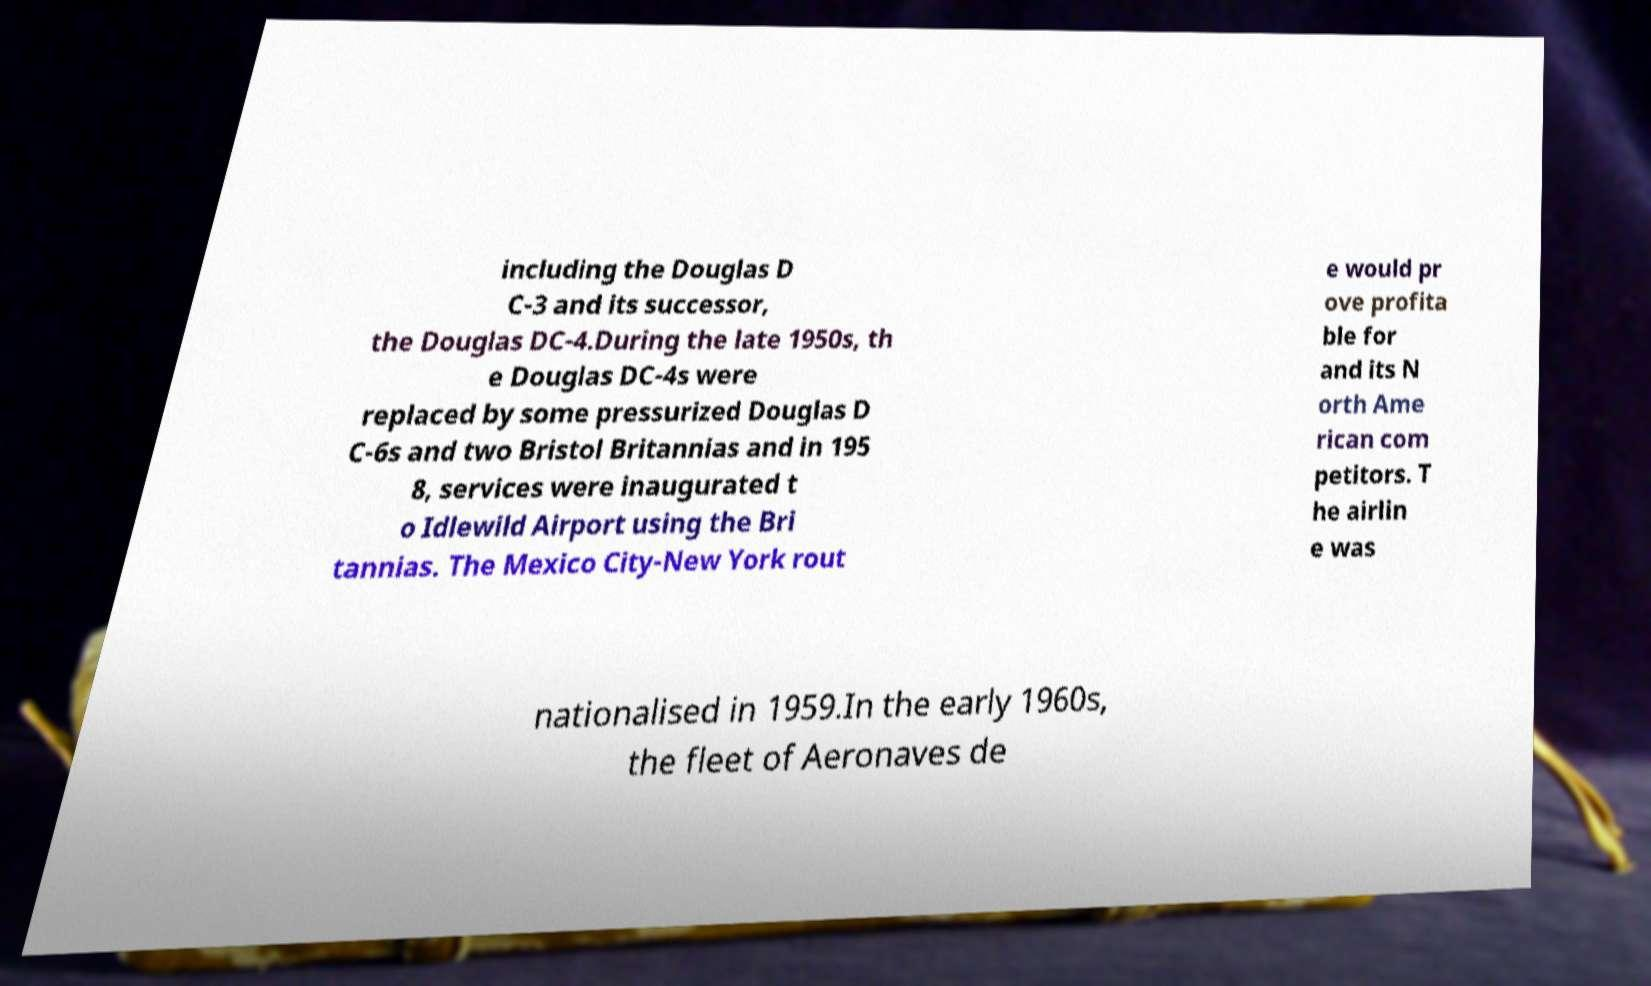There's text embedded in this image that I need extracted. Can you transcribe it verbatim? including the Douglas D C-3 and its successor, the Douglas DC-4.During the late 1950s, th e Douglas DC-4s were replaced by some pressurized Douglas D C-6s and two Bristol Britannias and in 195 8, services were inaugurated t o Idlewild Airport using the Bri tannias. The Mexico City-New York rout e would pr ove profita ble for and its N orth Ame rican com petitors. T he airlin e was nationalised in 1959.In the early 1960s, the fleet of Aeronaves de 